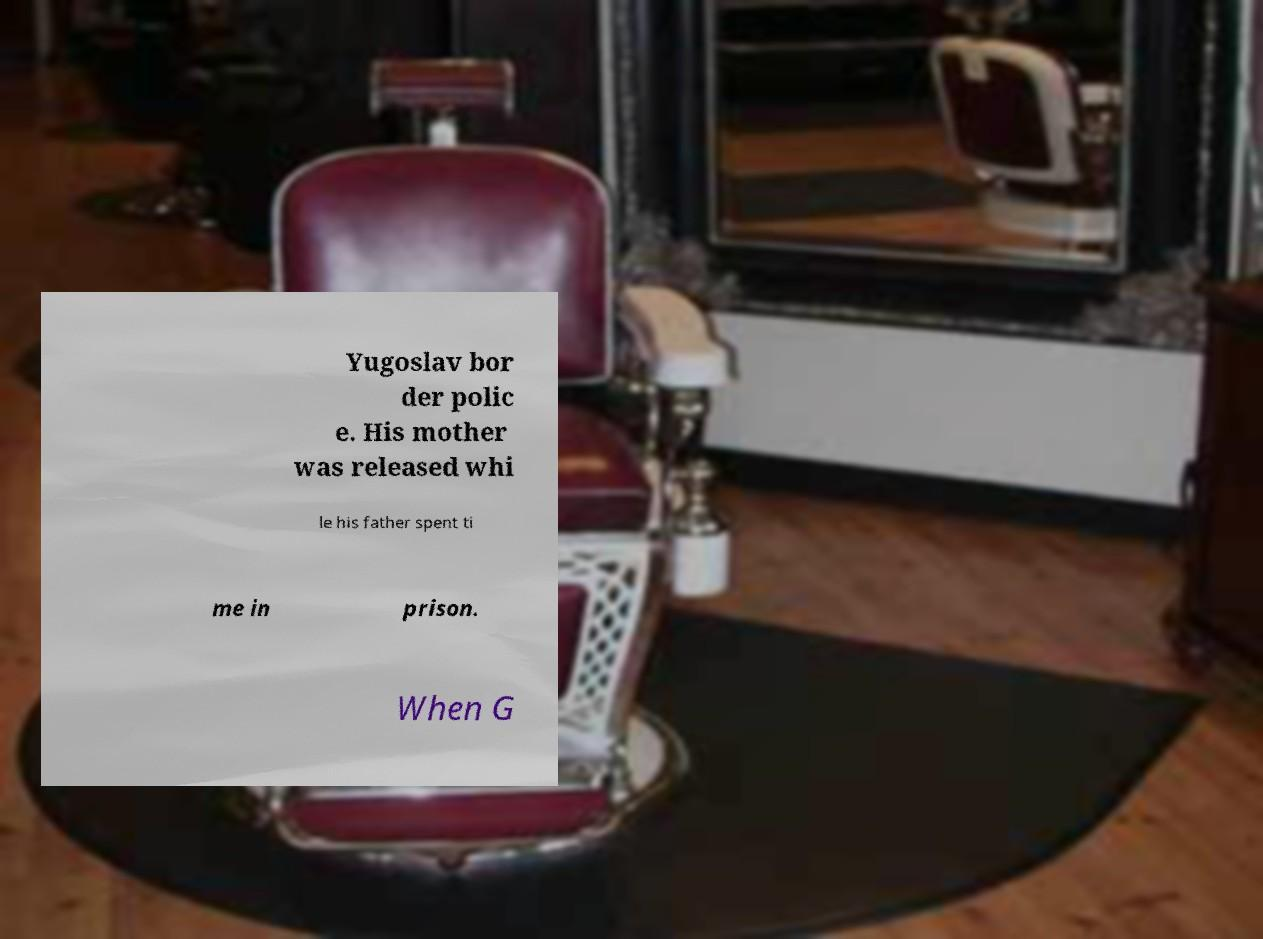For documentation purposes, I need the text within this image transcribed. Could you provide that? Yugoslav bor der polic e. His mother was released whi le his father spent ti me in prison. When G 